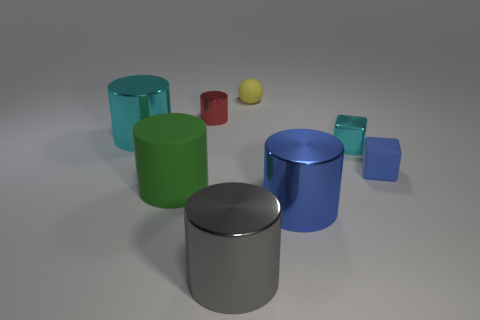What number of big green rubber cylinders are in front of the yellow object?
Make the answer very short. 1. There is a tiny thing that is the same shape as the large matte object; what is its color?
Your response must be concise. Red. There is a cylinder that is behind the blue shiny object and in front of the blue rubber block; what is its material?
Offer a terse response. Rubber. There is a cyan shiny object that is right of the rubber cylinder; is its size the same as the matte block?
Give a very brief answer. Yes. What is the large gray cylinder made of?
Your response must be concise. Metal. What is the color of the big metallic cylinder behind the large green rubber object?
Keep it short and to the point. Cyan. What number of big things are green cylinders or yellow cylinders?
Provide a succinct answer. 1. There is a shiny cylinder that is on the right side of the yellow object; is its color the same as the small matte object that is in front of the cyan cylinder?
Offer a very short reply. Yes. What number of other things are the same color as the small ball?
Your answer should be compact. 0. What number of gray things are tiny metallic cylinders or large rubber things?
Your response must be concise. 0. 